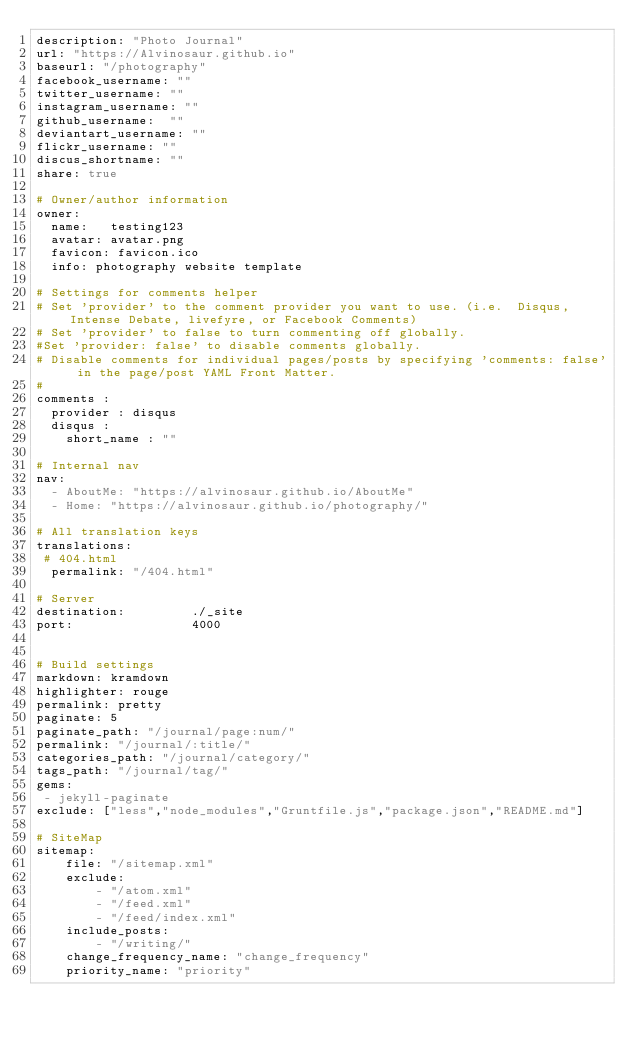Convert code to text. <code><loc_0><loc_0><loc_500><loc_500><_YAML_>description: "Photo Journal"
url: "https://Alvinosaur.github.io"
baseurl: "/photography"
facebook_username: ""
twitter_username: ""
instagram_username: ""
github_username:  ""
deviantart_username: ""
flickr_username: ""
discus_shortname: ""
share: true

# Owner/author information
owner:
  name:   testing123
  avatar: avatar.png
  favicon: favicon.ico
  info: photography website template

# Settings for comments helper
# Set 'provider' to the comment provider you want to use. (i.e.  Disqus, Intense Debate, livefyre, or Facebook Comments)
# Set 'provider' to false to turn commenting off globally.
#Set 'provider: false' to disable comments globally.
# Disable comments for individual pages/posts by specifying 'comments: false' in the page/post YAML Front Matter.
#
comments :
  provider : disqus
  disqus :
    short_name : ""

# Internal nav
nav:
  - AboutMe: "https://alvinosaur.github.io/AboutMe"
  - Home: "https://alvinosaur.github.io/photography/"

# All translation keys
translations:
 # 404.html
  permalink: "/404.html"

# Server
destination:      	 ./_site
port:             	 4000


# Build settings
markdown: kramdown
highlighter: rouge
permalink: pretty
paginate: 5
paginate_path: "/journal/page:num/"
permalink: "/journal/:title/"
categories_path: "/journal/category/"
tags_path: "/journal/tag/"
gems: 
 - jekyll-paginate
exclude: ["less","node_modules","Gruntfile.js","package.json","README.md"]

# SiteMap
sitemap:
    file: "/sitemap.xml"
    exclude:
        - "/atom.xml"
        - "/feed.xml"
        - "/feed/index.xml"
    include_posts:
        - "/writing/"
    change_frequency_name: "change_frequency"
    priority_name: "priority"
</code> 